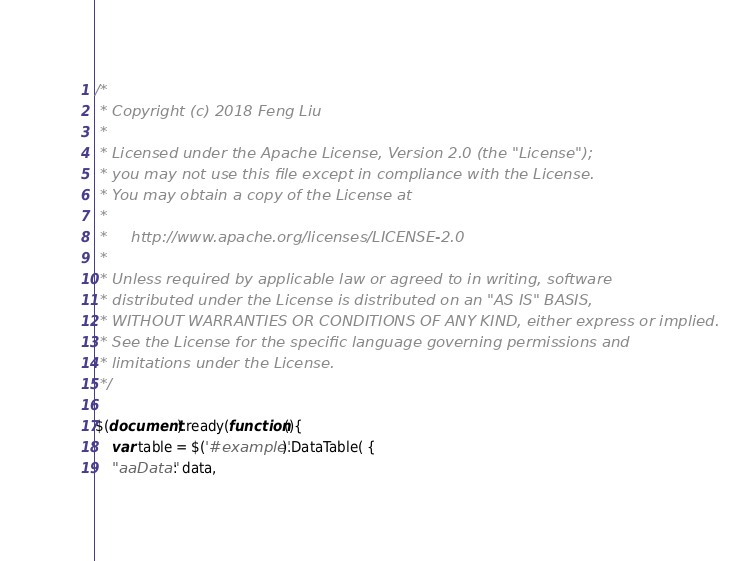Convert code to text. <code><loc_0><loc_0><loc_500><loc_500><_JavaScript_>/*
 * Copyright (c) 2018 Feng Liu
 *
 * Licensed under the Apache License, Version 2.0 (the "License");
 * you may not use this file except in compliance with the License.
 * You may obtain a copy of the License at
 *
 *     http://www.apache.org/licenses/LICENSE-2.0
 *
 * Unless required by applicable law or agreed to in writing, software
 * distributed under the License is distributed on an "AS IS" BASIS,
 * WITHOUT WARRANTIES OR CONDITIONS OF ANY KIND, either express or implied.
 * See the License for the specific language governing permissions and
 * limitations under the License.
 */

$(document).ready(function(){
	var table = $('#example').DataTable( {
   	"aaData": data, </code> 